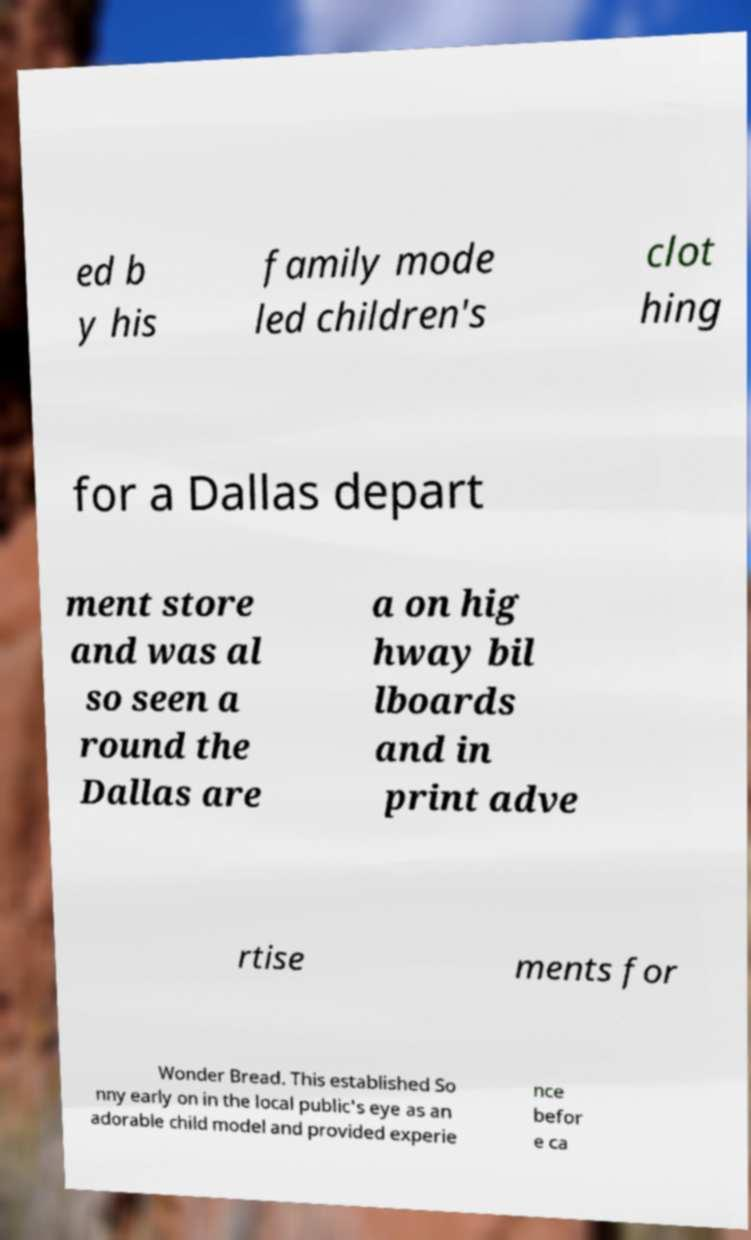There's text embedded in this image that I need extracted. Can you transcribe it verbatim? ed b y his family mode led children's clot hing for a Dallas depart ment store and was al so seen a round the Dallas are a on hig hway bil lboards and in print adve rtise ments for Wonder Bread. This established So nny early on in the local public's eye as an adorable child model and provided experie nce befor e ca 